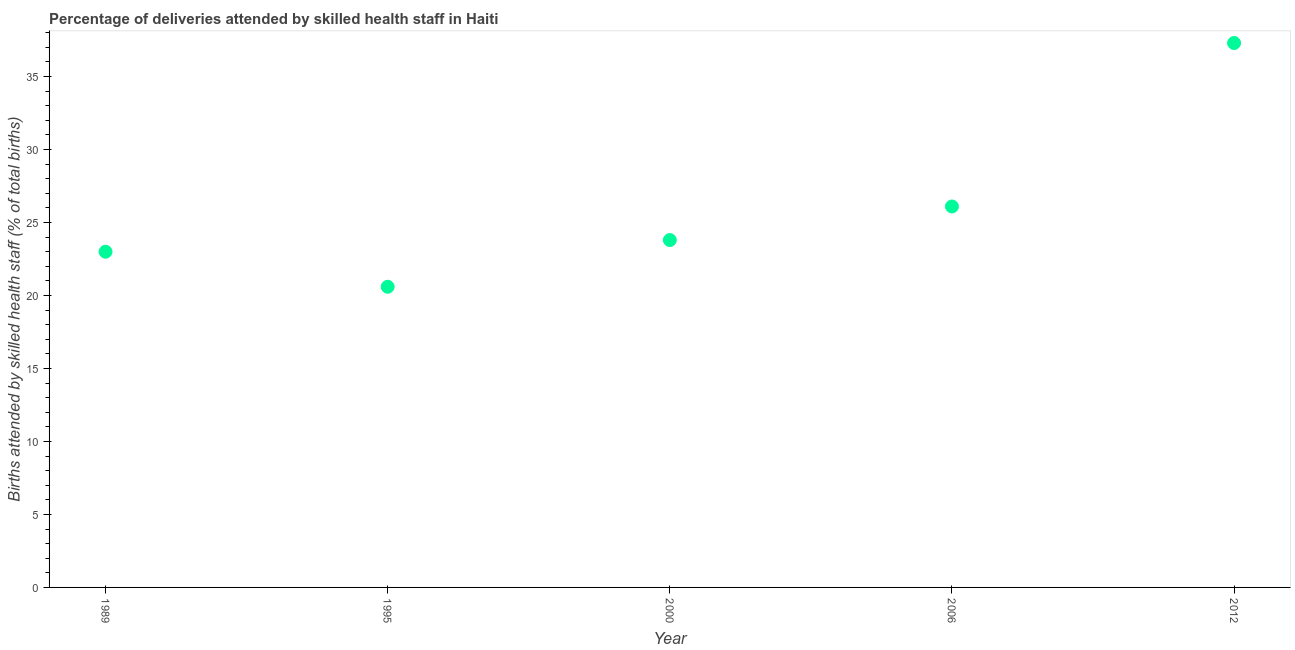Across all years, what is the maximum number of births attended by skilled health staff?
Your response must be concise. 37.3. Across all years, what is the minimum number of births attended by skilled health staff?
Your answer should be very brief. 20.6. In which year was the number of births attended by skilled health staff maximum?
Provide a short and direct response. 2012. What is the sum of the number of births attended by skilled health staff?
Keep it short and to the point. 130.8. What is the difference between the number of births attended by skilled health staff in 1995 and 2000?
Ensure brevity in your answer.  -3.2. What is the average number of births attended by skilled health staff per year?
Your response must be concise. 26.16. What is the median number of births attended by skilled health staff?
Keep it short and to the point. 23.8. What is the ratio of the number of births attended by skilled health staff in 1995 to that in 2000?
Keep it short and to the point. 0.87. Is the number of births attended by skilled health staff in 2000 less than that in 2006?
Provide a succinct answer. Yes. Is the difference between the number of births attended by skilled health staff in 2000 and 2006 greater than the difference between any two years?
Provide a succinct answer. No. What is the difference between the highest and the second highest number of births attended by skilled health staff?
Your response must be concise. 11.2. What is the difference between the highest and the lowest number of births attended by skilled health staff?
Give a very brief answer. 16.7. Does the number of births attended by skilled health staff monotonically increase over the years?
Offer a very short reply. No. How many years are there in the graph?
Offer a very short reply. 5. Does the graph contain any zero values?
Offer a very short reply. No. Does the graph contain grids?
Offer a terse response. No. What is the title of the graph?
Ensure brevity in your answer.  Percentage of deliveries attended by skilled health staff in Haiti. What is the label or title of the X-axis?
Give a very brief answer. Year. What is the label or title of the Y-axis?
Offer a terse response. Births attended by skilled health staff (% of total births). What is the Births attended by skilled health staff (% of total births) in 1989?
Provide a succinct answer. 23. What is the Births attended by skilled health staff (% of total births) in 1995?
Offer a very short reply. 20.6. What is the Births attended by skilled health staff (% of total births) in 2000?
Make the answer very short. 23.8. What is the Births attended by skilled health staff (% of total births) in 2006?
Keep it short and to the point. 26.1. What is the Births attended by skilled health staff (% of total births) in 2012?
Make the answer very short. 37.3. What is the difference between the Births attended by skilled health staff (% of total births) in 1989 and 1995?
Keep it short and to the point. 2.4. What is the difference between the Births attended by skilled health staff (% of total births) in 1989 and 2006?
Provide a succinct answer. -3.1. What is the difference between the Births attended by skilled health staff (% of total births) in 1989 and 2012?
Provide a succinct answer. -14.3. What is the difference between the Births attended by skilled health staff (% of total births) in 1995 and 2012?
Ensure brevity in your answer.  -16.7. What is the difference between the Births attended by skilled health staff (% of total births) in 2000 and 2006?
Offer a very short reply. -2.3. What is the ratio of the Births attended by skilled health staff (% of total births) in 1989 to that in 1995?
Provide a succinct answer. 1.12. What is the ratio of the Births attended by skilled health staff (% of total births) in 1989 to that in 2006?
Provide a succinct answer. 0.88. What is the ratio of the Births attended by skilled health staff (% of total births) in 1989 to that in 2012?
Give a very brief answer. 0.62. What is the ratio of the Births attended by skilled health staff (% of total births) in 1995 to that in 2000?
Keep it short and to the point. 0.87. What is the ratio of the Births attended by skilled health staff (% of total births) in 1995 to that in 2006?
Your answer should be compact. 0.79. What is the ratio of the Births attended by skilled health staff (% of total births) in 1995 to that in 2012?
Your response must be concise. 0.55. What is the ratio of the Births attended by skilled health staff (% of total births) in 2000 to that in 2006?
Your answer should be compact. 0.91. What is the ratio of the Births attended by skilled health staff (% of total births) in 2000 to that in 2012?
Keep it short and to the point. 0.64. What is the ratio of the Births attended by skilled health staff (% of total births) in 2006 to that in 2012?
Ensure brevity in your answer.  0.7. 